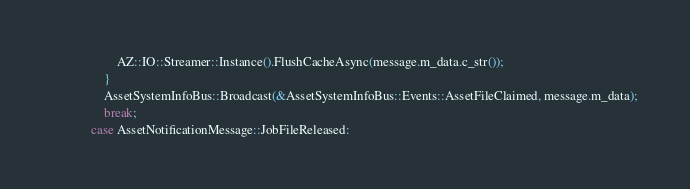Convert code to text. <code><loc_0><loc_0><loc_500><loc_500><_C++_>                    AZ::IO::Streamer::Instance().FlushCacheAsync(message.m_data.c_str());
                }
                AssetSystemInfoBus::Broadcast(&AssetSystemInfoBus::Events::AssetFileClaimed, message.m_data);
                break;
            case AssetNotificationMessage::JobFileReleased:</code> 